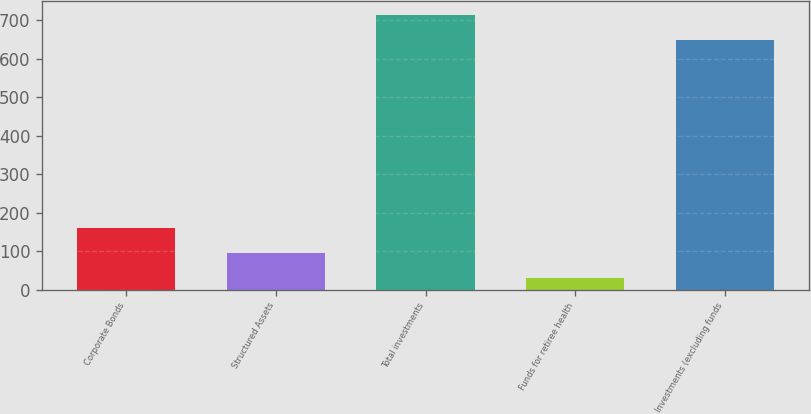<chart> <loc_0><loc_0><loc_500><loc_500><bar_chart><fcel>Corporate Bonds<fcel>Structured Assets<fcel>Total investments<fcel>Funds for retiree health<fcel>Investments (excluding funds<nl><fcel>160<fcel>95<fcel>715<fcel>30<fcel>650<nl></chart> 